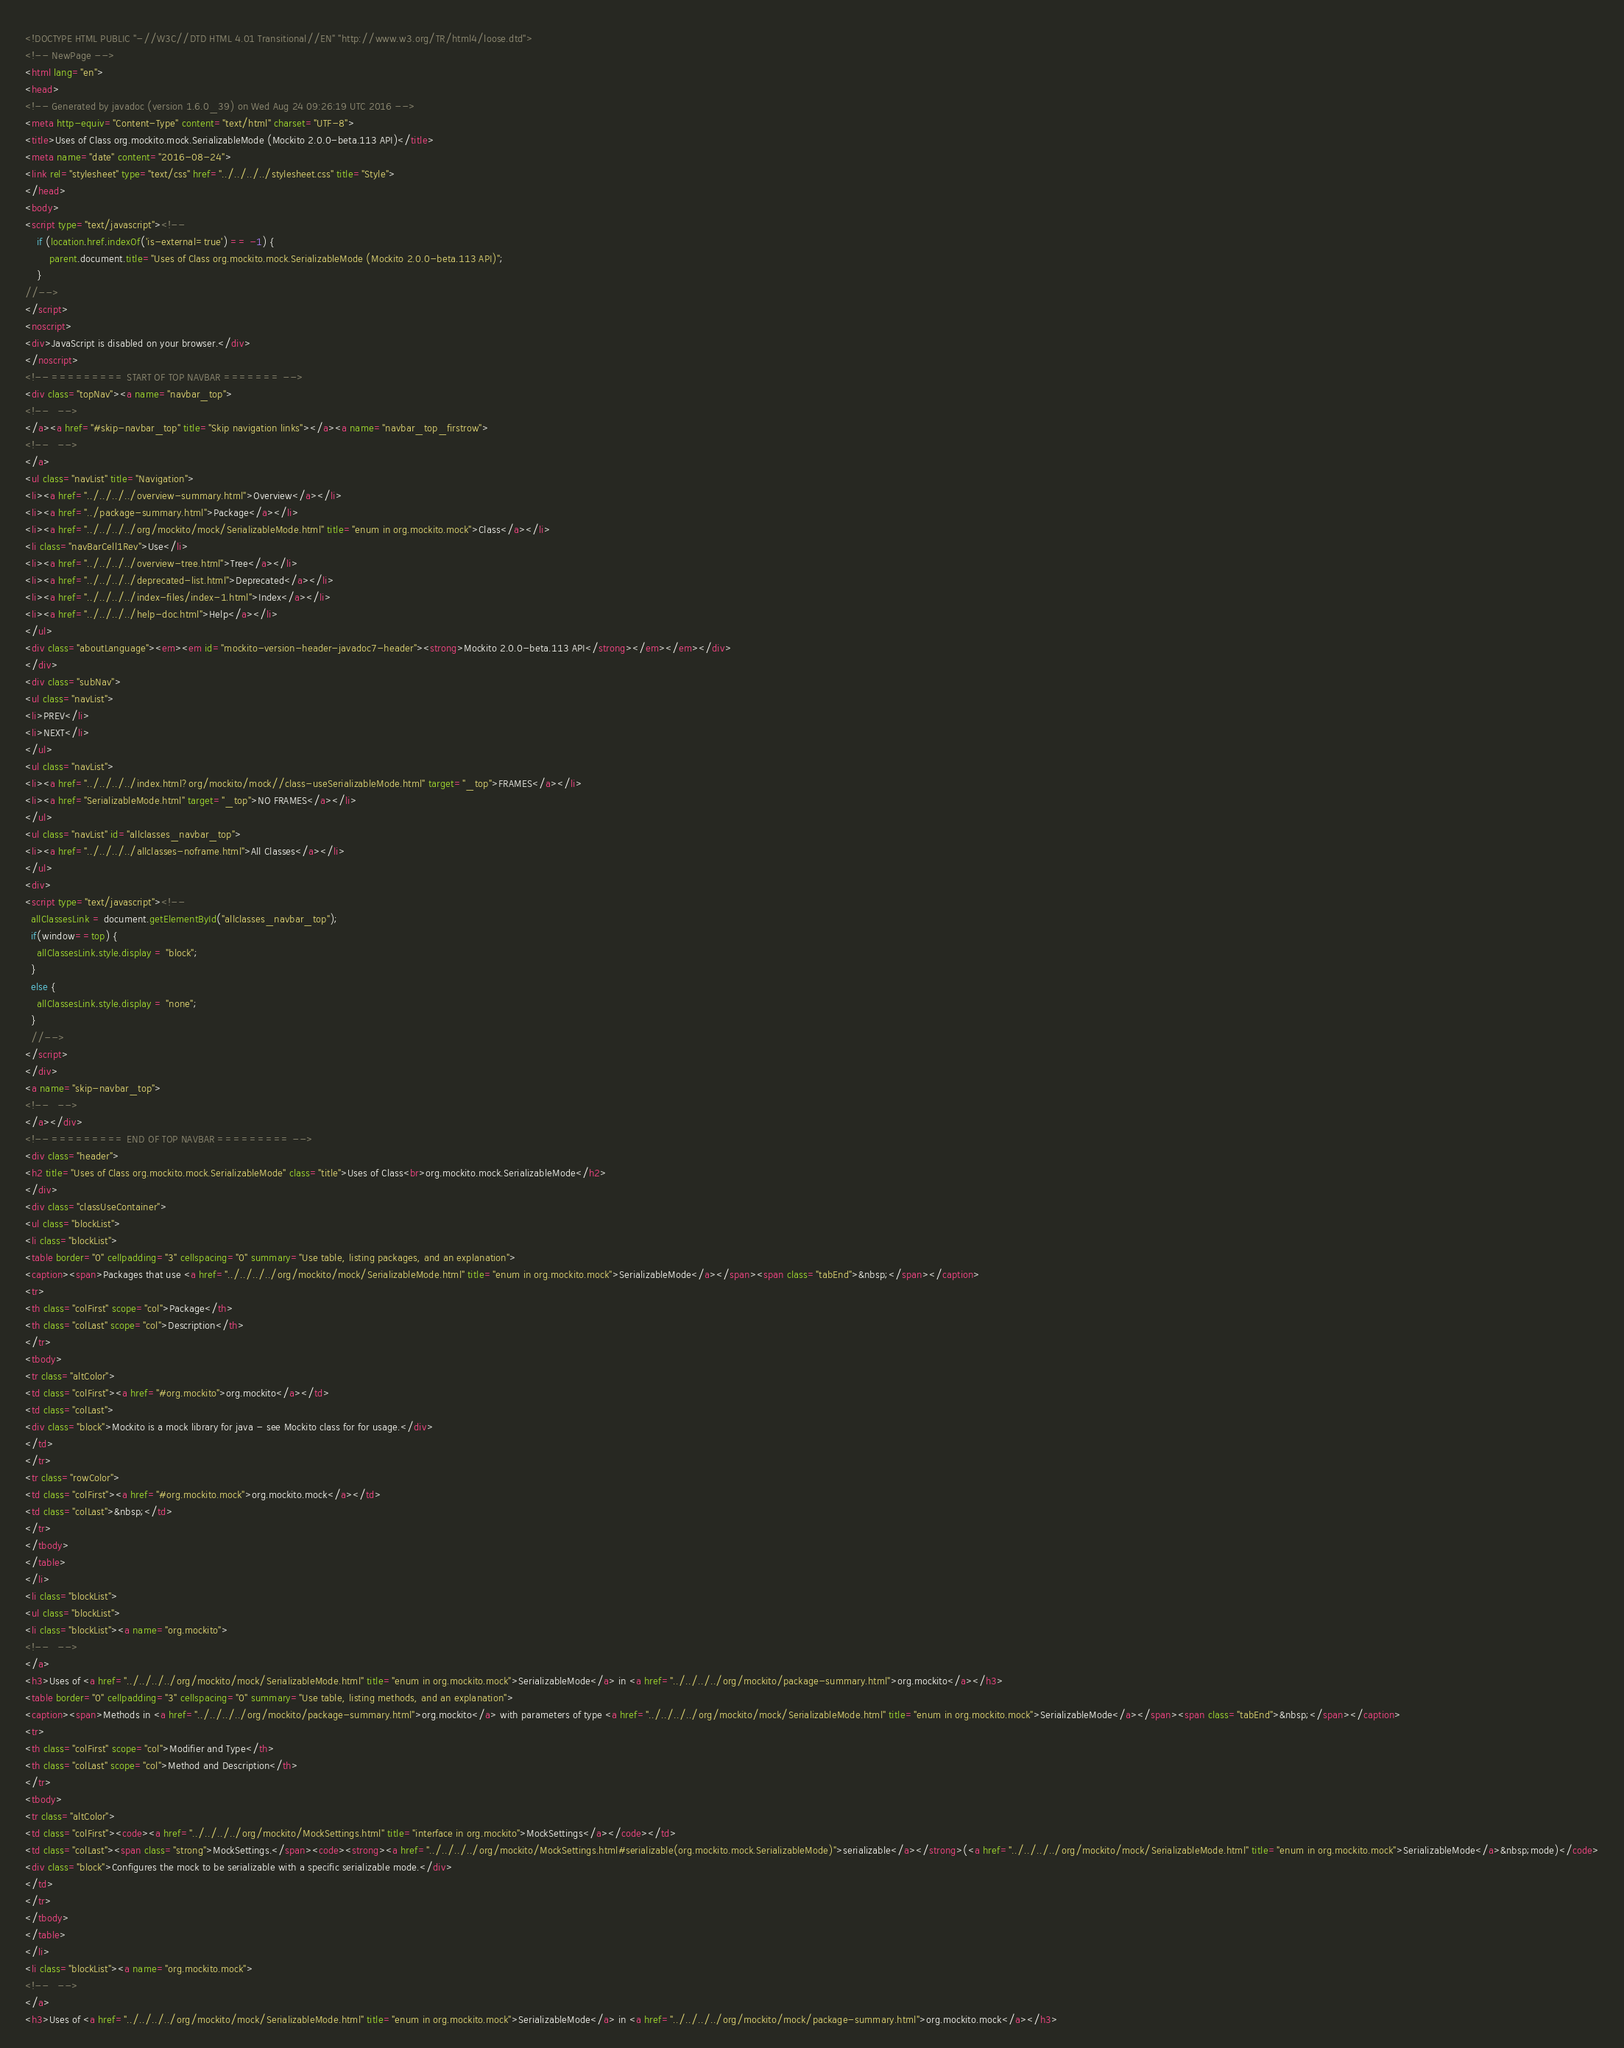Convert code to text. <code><loc_0><loc_0><loc_500><loc_500><_HTML_><!DOCTYPE HTML PUBLIC "-//W3C//DTD HTML 4.01 Transitional//EN" "http://www.w3.org/TR/html4/loose.dtd">
<!-- NewPage -->
<html lang="en">
<head>
<!-- Generated by javadoc (version 1.6.0_39) on Wed Aug 24 09:26:19 UTC 2016 -->
<meta http-equiv="Content-Type" content="text/html" charset="UTF-8">
<title>Uses of Class org.mockito.mock.SerializableMode (Mockito 2.0.0-beta.113 API)</title>
<meta name="date" content="2016-08-24">
<link rel="stylesheet" type="text/css" href="../../../../stylesheet.css" title="Style">
</head>
<body>
<script type="text/javascript"><!--
    if (location.href.indexOf('is-external=true') == -1) {
        parent.document.title="Uses of Class org.mockito.mock.SerializableMode (Mockito 2.0.0-beta.113 API)";
    }
//-->
</script>
<noscript>
<div>JavaScript is disabled on your browser.</div>
</noscript>
<!-- ========= START OF TOP NAVBAR ======= -->
<div class="topNav"><a name="navbar_top">
<!--   -->
</a><a href="#skip-navbar_top" title="Skip navigation links"></a><a name="navbar_top_firstrow">
<!--   -->
</a>
<ul class="navList" title="Navigation">
<li><a href="../../../../overview-summary.html">Overview</a></li>
<li><a href="../package-summary.html">Package</a></li>
<li><a href="../../../../org/mockito/mock/SerializableMode.html" title="enum in org.mockito.mock">Class</a></li>
<li class="navBarCell1Rev">Use</li>
<li><a href="../../../../overview-tree.html">Tree</a></li>
<li><a href="../../../../deprecated-list.html">Deprecated</a></li>
<li><a href="../../../../index-files/index-1.html">Index</a></li>
<li><a href="../../../../help-doc.html">Help</a></li>
</ul>
<div class="aboutLanguage"><em><em id="mockito-version-header-javadoc7-header"><strong>Mockito 2.0.0-beta.113 API</strong></em></em></div>
</div>
<div class="subNav">
<ul class="navList">
<li>PREV</li>
<li>NEXT</li>
</ul>
<ul class="navList">
<li><a href="../../../../index.html?org/mockito/mock//class-useSerializableMode.html" target="_top">FRAMES</a></li>
<li><a href="SerializableMode.html" target="_top">NO FRAMES</a></li>
</ul>
<ul class="navList" id="allclasses_navbar_top">
<li><a href="../../../../allclasses-noframe.html">All Classes</a></li>
</ul>
<div>
<script type="text/javascript"><!--
  allClassesLink = document.getElementById("allclasses_navbar_top");
  if(window==top) {
    allClassesLink.style.display = "block";
  }
  else {
    allClassesLink.style.display = "none";
  }
  //-->
</script>
</div>
<a name="skip-navbar_top">
<!--   -->
</a></div>
<!-- ========= END OF TOP NAVBAR ========= -->
<div class="header">
<h2 title="Uses of Class org.mockito.mock.SerializableMode" class="title">Uses of Class<br>org.mockito.mock.SerializableMode</h2>
</div>
<div class="classUseContainer">
<ul class="blockList">
<li class="blockList">
<table border="0" cellpadding="3" cellspacing="0" summary="Use table, listing packages, and an explanation">
<caption><span>Packages that use <a href="../../../../org/mockito/mock/SerializableMode.html" title="enum in org.mockito.mock">SerializableMode</a></span><span class="tabEnd">&nbsp;</span></caption>
<tr>
<th class="colFirst" scope="col">Package</th>
<th class="colLast" scope="col">Description</th>
</tr>
<tbody>
<tr class="altColor">
<td class="colFirst"><a href="#org.mockito">org.mockito</a></td>
<td class="colLast">
<div class="block">Mockito is a mock library for java - see Mockito class for for usage.</div>
</td>
</tr>
<tr class="rowColor">
<td class="colFirst"><a href="#org.mockito.mock">org.mockito.mock</a></td>
<td class="colLast">&nbsp;</td>
</tr>
</tbody>
</table>
</li>
<li class="blockList">
<ul class="blockList">
<li class="blockList"><a name="org.mockito">
<!--   -->
</a>
<h3>Uses of <a href="../../../../org/mockito/mock/SerializableMode.html" title="enum in org.mockito.mock">SerializableMode</a> in <a href="../../../../org/mockito/package-summary.html">org.mockito</a></h3>
<table border="0" cellpadding="3" cellspacing="0" summary="Use table, listing methods, and an explanation">
<caption><span>Methods in <a href="../../../../org/mockito/package-summary.html">org.mockito</a> with parameters of type <a href="../../../../org/mockito/mock/SerializableMode.html" title="enum in org.mockito.mock">SerializableMode</a></span><span class="tabEnd">&nbsp;</span></caption>
<tr>
<th class="colFirst" scope="col">Modifier and Type</th>
<th class="colLast" scope="col">Method and Description</th>
</tr>
<tbody>
<tr class="altColor">
<td class="colFirst"><code><a href="../../../../org/mockito/MockSettings.html" title="interface in org.mockito">MockSettings</a></code></td>
<td class="colLast"><span class="strong">MockSettings.</span><code><strong><a href="../../../../org/mockito/MockSettings.html#serializable(org.mockito.mock.SerializableMode)">serializable</a></strong>(<a href="../../../../org/mockito/mock/SerializableMode.html" title="enum in org.mockito.mock">SerializableMode</a>&nbsp;mode)</code>
<div class="block">Configures the mock to be serializable with a specific serializable mode.</div>
</td>
</tr>
</tbody>
</table>
</li>
<li class="blockList"><a name="org.mockito.mock">
<!--   -->
</a>
<h3>Uses of <a href="../../../../org/mockito/mock/SerializableMode.html" title="enum in org.mockito.mock">SerializableMode</a> in <a href="../../../../org/mockito/mock/package-summary.html">org.mockito.mock</a></h3></code> 